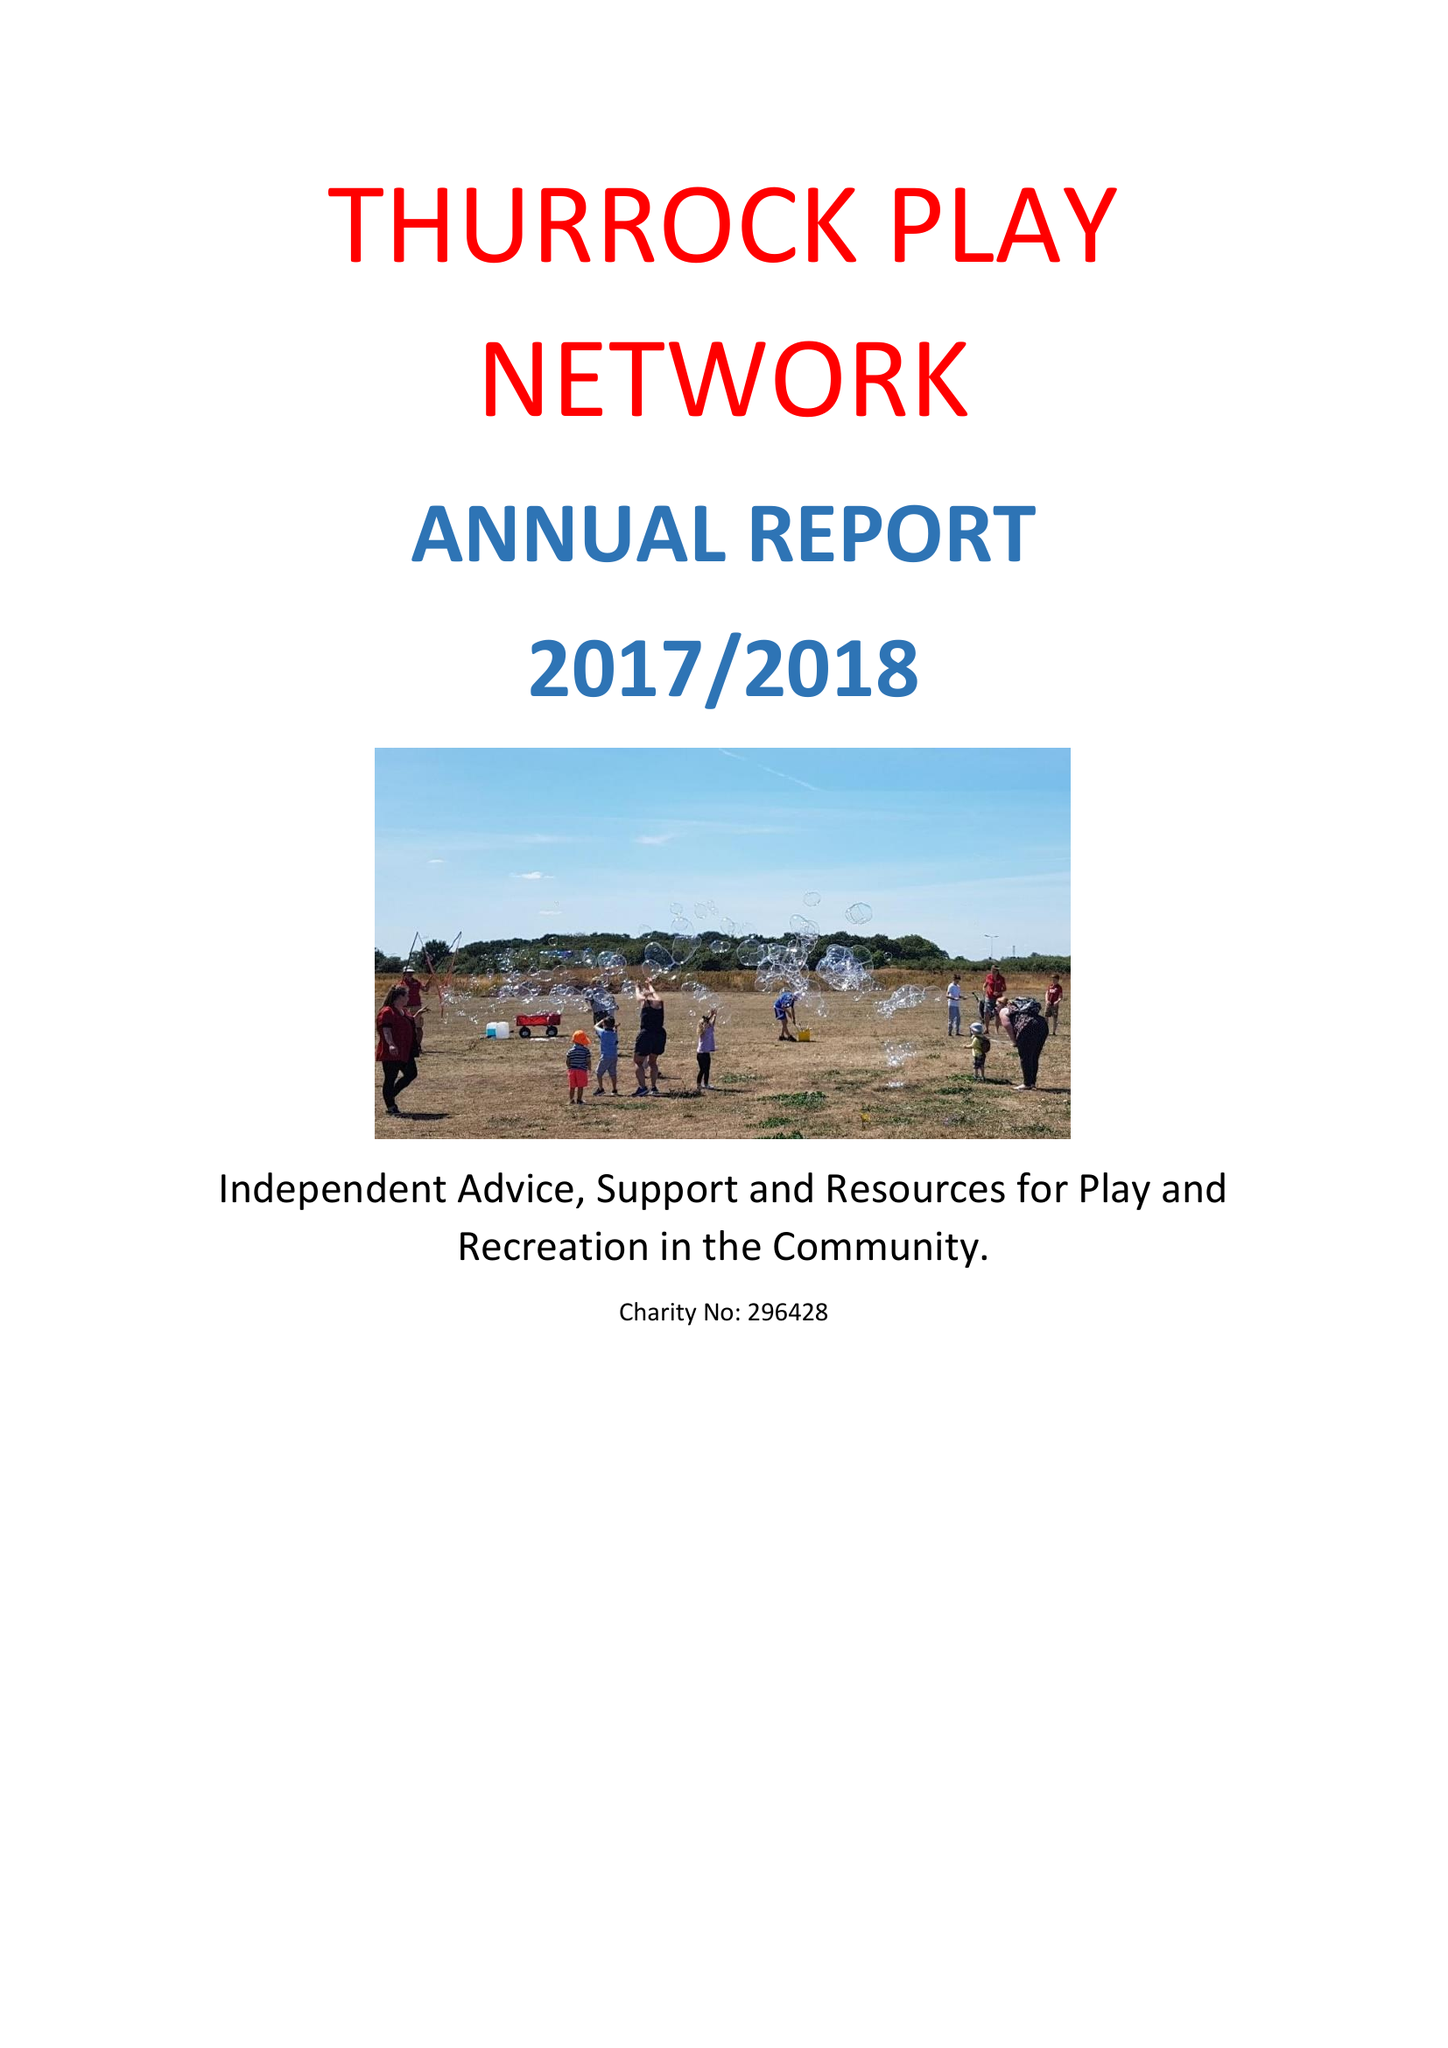What is the value for the charity_name?
Answer the question using a single word or phrase. Thurrock Play Network 